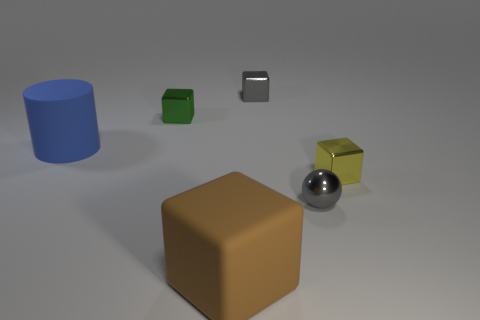Add 3 gray things. How many objects exist? 9 Subtract all blocks. How many objects are left? 2 Subtract all small cyan balls. Subtract all small things. How many objects are left? 2 Add 1 gray balls. How many gray balls are left? 2 Add 1 tiny gray metal things. How many tiny gray metal things exist? 3 Subtract 0 brown balls. How many objects are left? 6 